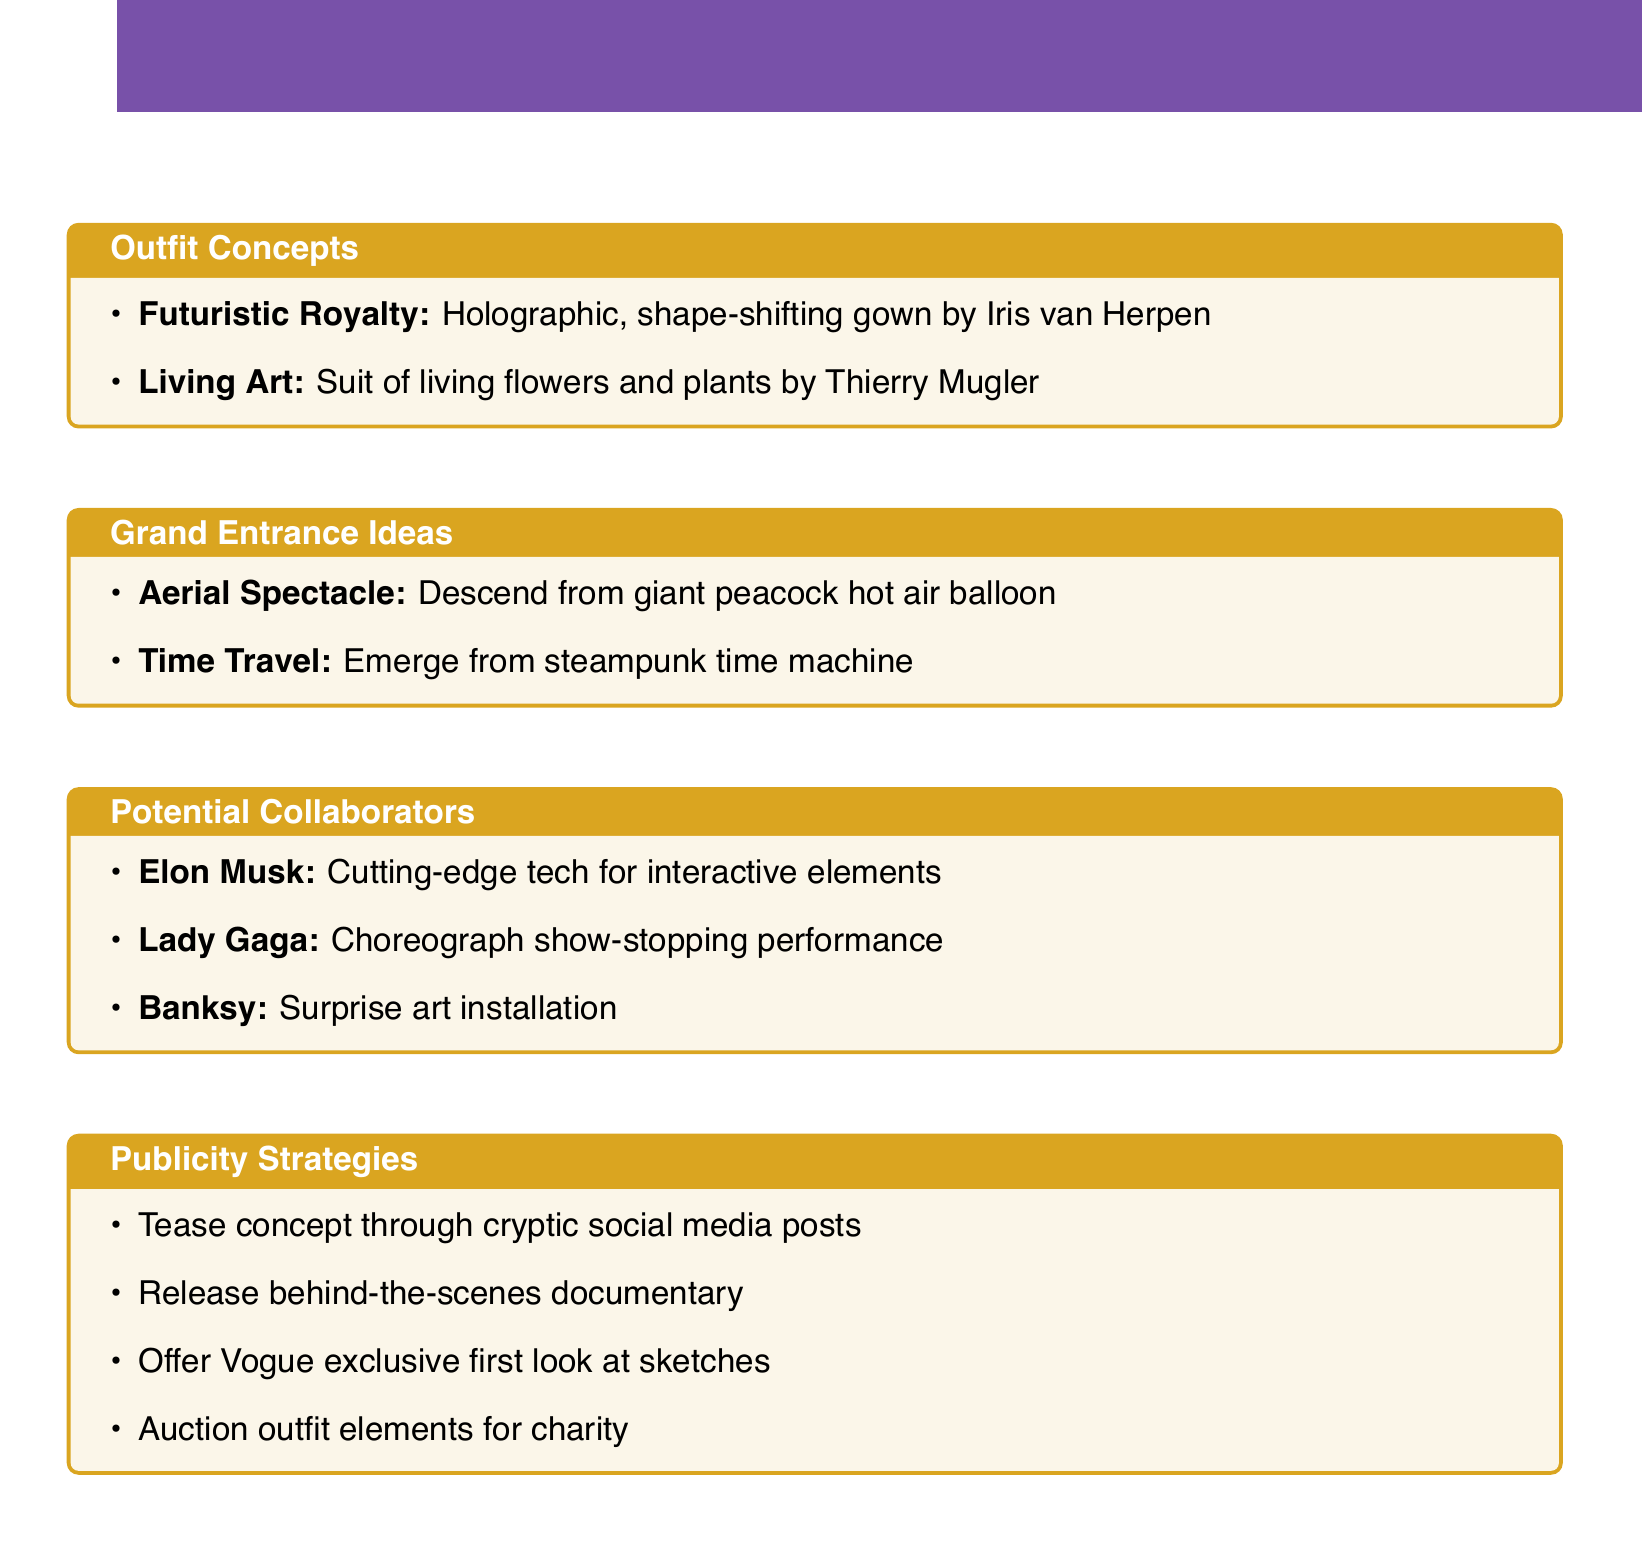What is the theme of the first outfit concept? The first outfit concept is categorized under the theme titled "Futuristic Royalty".
Answer: Futuristic Royalty Who is the designer of the "Living Art" outfit? The outfit labeled "Living Art" is designed by Thierry Mugler.
Answer: Thierry Mugler What is the concept of the first grand entrance idea? The first grand entrance idea is described as an "Aerial Spectacle".
Answer: Aerial Spectacle Which collaborator is associated with the "Time Travel" entrance idea? The entrance idea of "Time Travel" lists Industrial Light & Magic as its collaborator.
Answer: Industrial Light & Magic What unique material is used for the "Living Art" outfit? The "Living Art" outfit is made entirely of living flowers and plants.
Answer: Living flowers and plants Who is suggested to create a surprise art installation? The document suggests Banksy as the artist for the surprise art installation.
Answer: Banksy What strategy involves releasing a documentary? The strategy that involves a documentary is to release a behind-the-scenes documentary about the creation process.
Answer: Behind-the-scenes documentary How many potential collaborators are listed in the document? The document mentions three potential collaborators for the project.
Answer: Three 